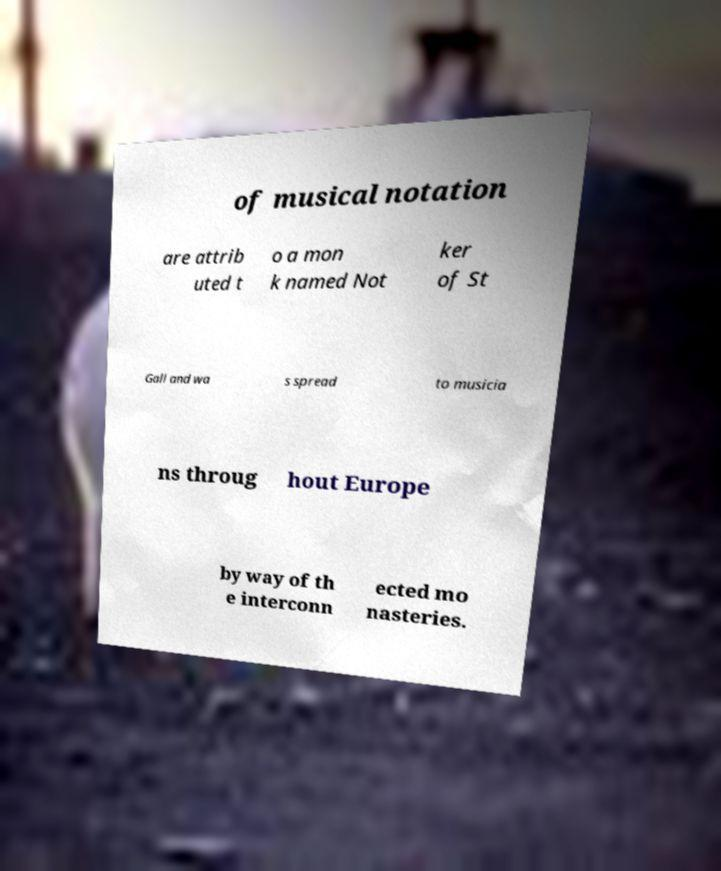Can you accurately transcribe the text from the provided image for me? of musical notation are attrib uted t o a mon k named Not ker of St Gall and wa s spread to musicia ns throug hout Europe by way of th e interconn ected mo nasteries. 